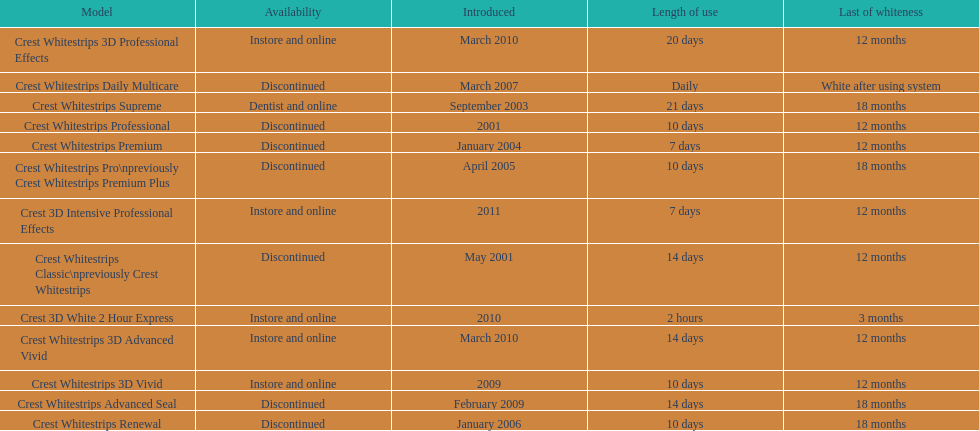Crest 3d intensive professional effects and crest whitestrips 3d professional effects both have a lasting whiteness of how many months? 12 months. 